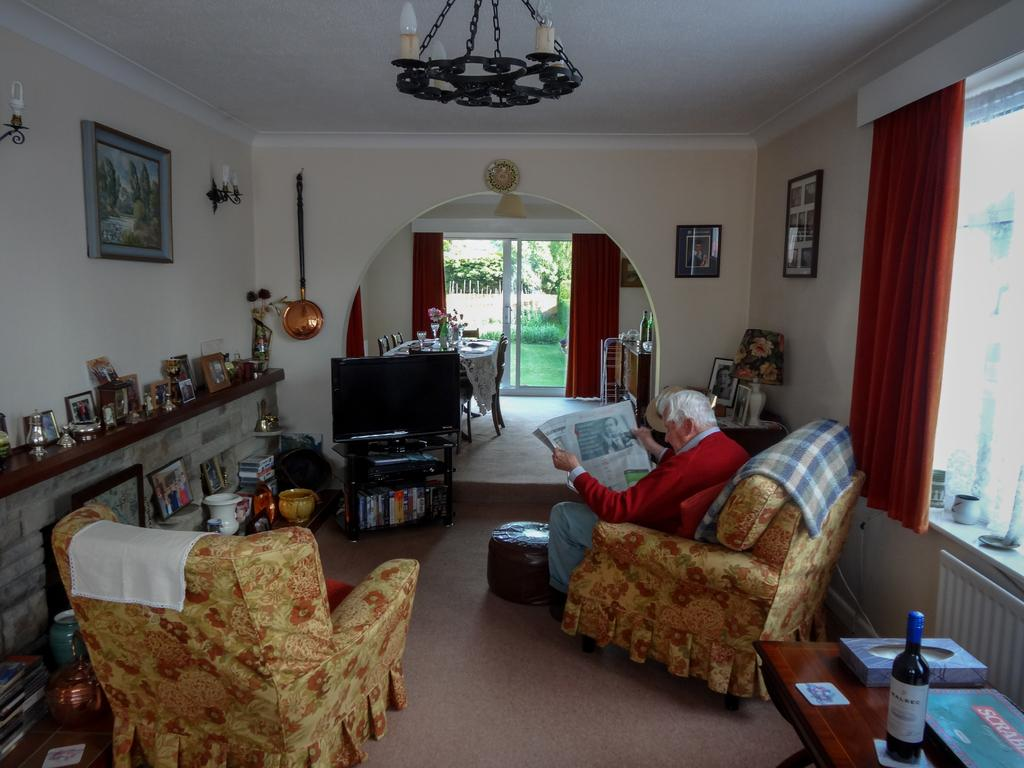Who is present in the image? There is a man in the image. What is the man doing in the image? The man is sitting on a chair and reading a newspaper. What can be seen in the room besides the man? There is a TV in the room. Are there any decorative items visible in the image? Yes, there are decorative items on a table or rack. How does the man smash the stream of water in the image? There is no stream of water or any smashing action in the image; the man is sitting and reading a newspaper. 